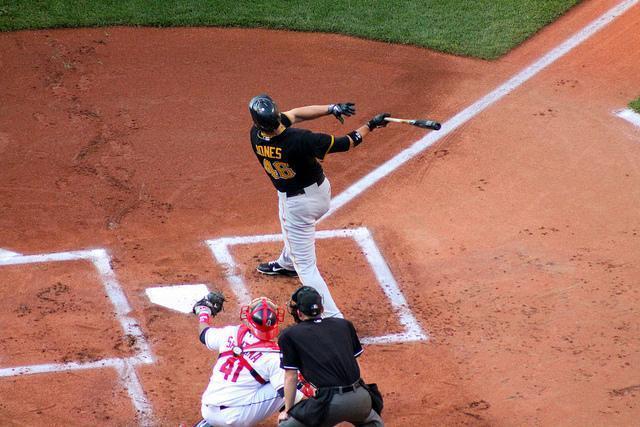How many people can you see?
Give a very brief answer. 3. 